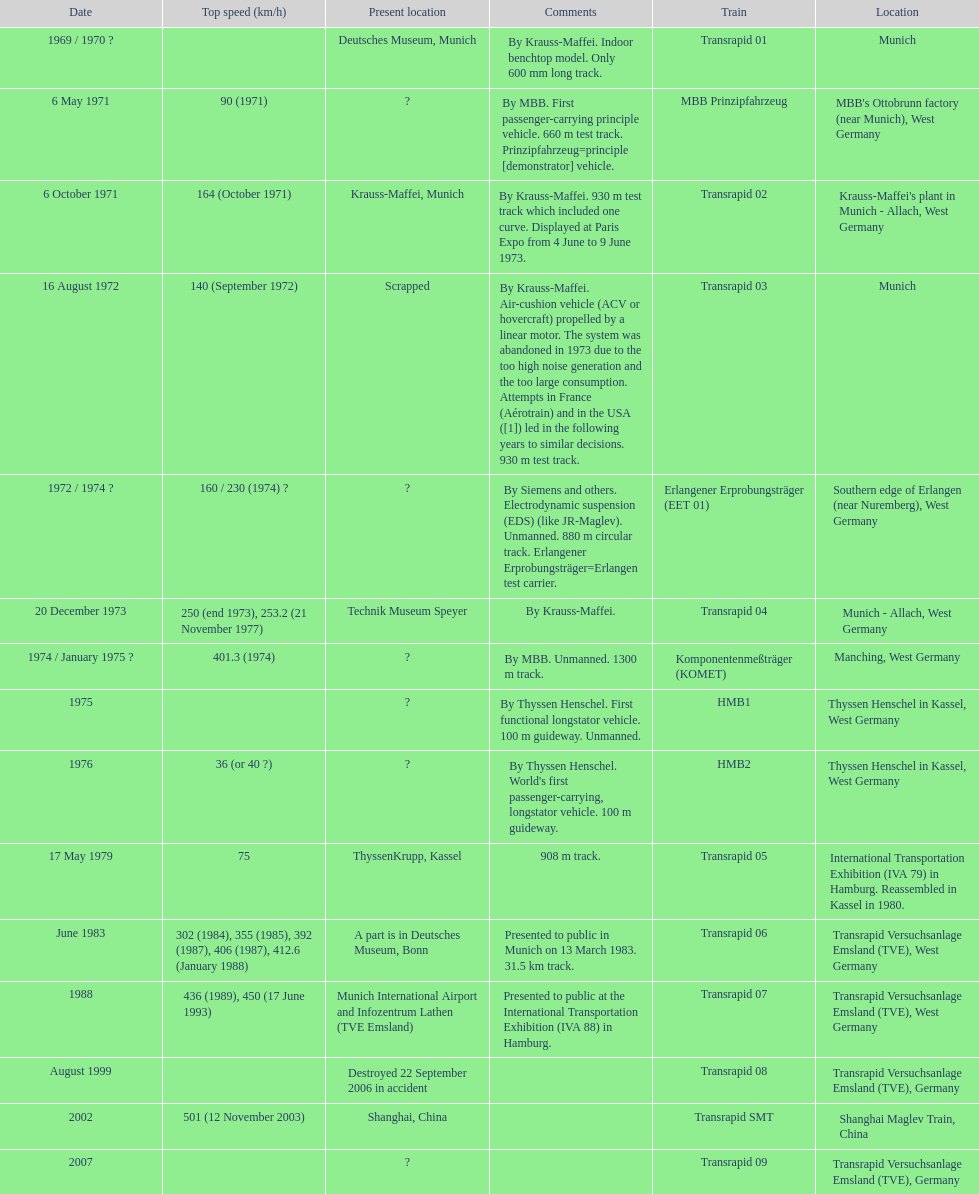What is the number of trains that were either scrapped or destroyed? 2. 